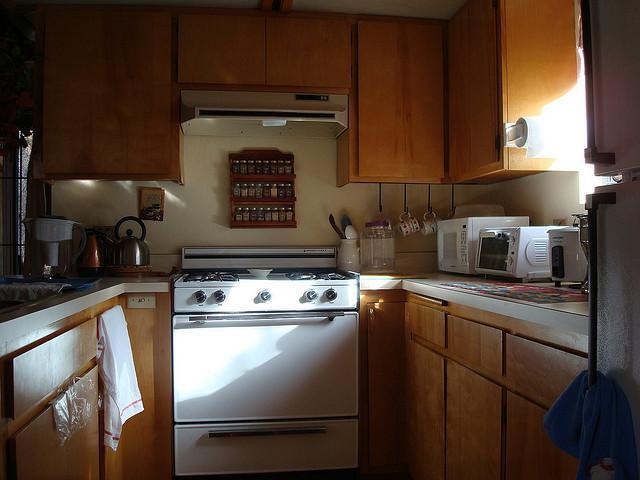What would someone use the objects above the stove for?
Choose the right answer and clarify with the format: 'Answer: answer
Rationale: rationale.'
Options: Teaching, drinking, seasoning, cleaning. Answer: seasoning.
Rationale: There is a spice rack above the stove. spices are not used for cleaning, teaching, or drinking. What is the shorter rectangular appliance called?
Choose the correct response and explain in the format: 'Answer: answer
Rationale: rationale.'
Options: Air conditioner, toaster oven, microwave, food dehydrator. Answer: microwave.
Rationale: The short rectangular appliance on the counter is a toaster oven. 